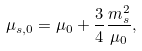Convert formula to latex. <formula><loc_0><loc_0><loc_500><loc_500>\mu _ { s , 0 } = \mu _ { 0 } + \frac { 3 } { 4 } \frac { m ^ { 2 } _ { s } } { \mu _ { 0 } } ,</formula> 